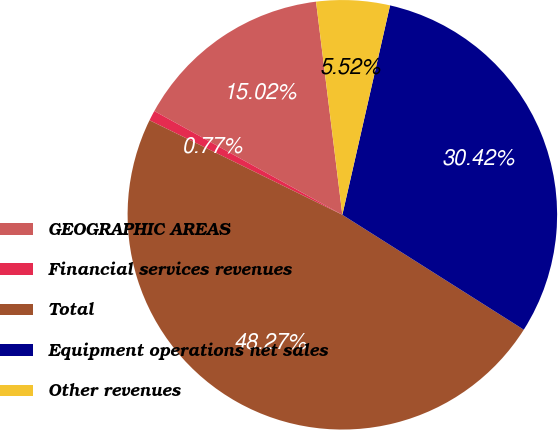Convert chart. <chart><loc_0><loc_0><loc_500><loc_500><pie_chart><fcel>GEOGRAPHIC AREAS<fcel>Financial services revenues<fcel>Total<fcel>Equipment operations net sales<fcel>Other revenues<nl><fcel>15.02%<fcel>0.77%<fcel>48.27%<fcel>30.42%<fcel>5.52%<nl></chart> 